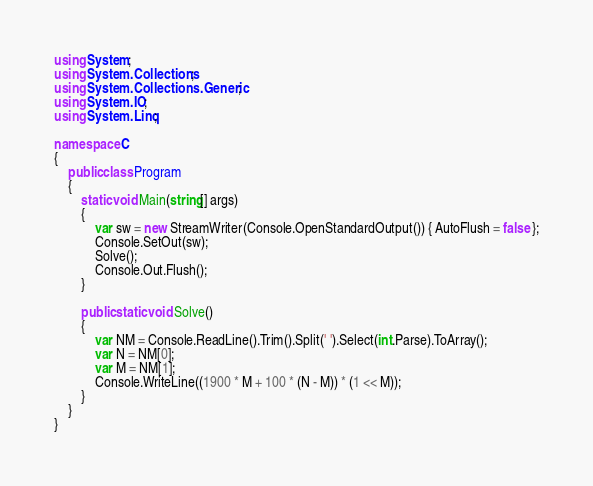<code> <loc_0><loc_0><loc_500><loc_500><_C#_>using System;
using System.Collections;
using System.Collections.Generic;
using System.IO;
using System.Linq;

namespace C
{
    public class Program
    {
        static void Main(string[] args)
        {
            var sw = new StreamWriter(Console.OpenStandardOutput()) { AutoFlush = false };
            Console.SetOut(sw);
            Solve();
            Console.Out.Flush();
        }

        public static void Solve()
        {
            var NM = Console.ReadLine().Trim().Split(' ').Select(int.Parse).ToArray();
            var N = NM[0];
            var M = NM[1];
            Console.WriteLine((1900 * M + 100 * (N - M)) * (1 << M));
        }
    }
}
</code> 